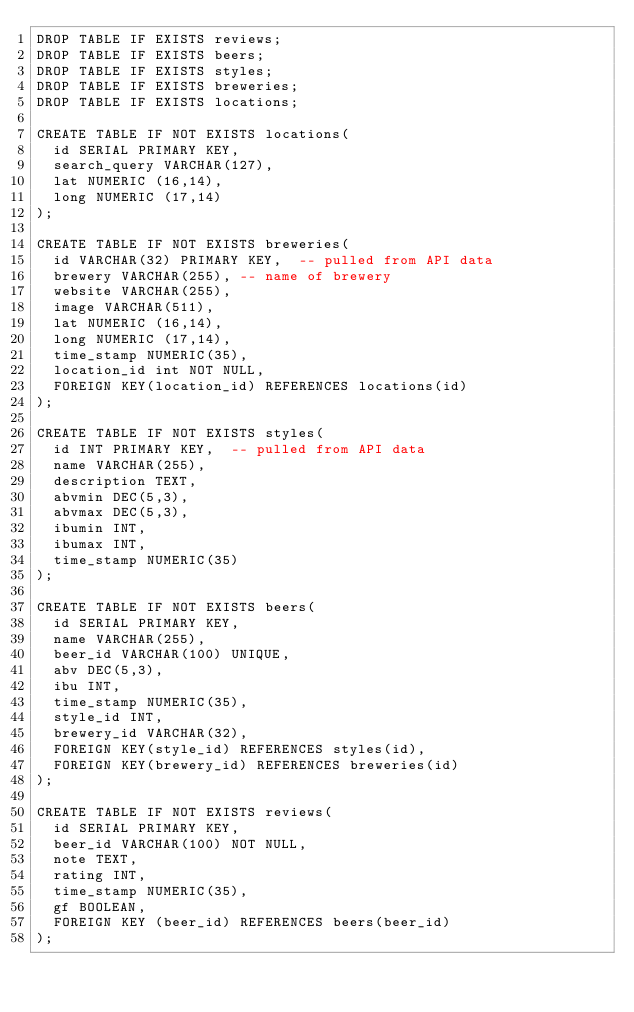Convert code to text. <code><loc_0><loc_0><loc_500><loc_500><_SQL_>DROP TABLE IF EXISTS reviews;
DROP TABLE IF EXISTS beers; 
DROP TABLE IF EXISTS styles;
DROP TABLE IF EXISTS breweries;
DROP TABLE IF EXISTS locations;

CREATE TABLE IF NOT EXISTS locations(
  id SERIAL PRIMARY KEY,
  search_query VARCHAR(127),
  lat NUMERIC (16,14),
  long NUMERIC (17,14)
);

CREATE TABLE IF NOT EXISTS breweries(
  id VARCHAR(32) PRIMARY KEY,  -- pulled from API data
  brewery VARCHAR(255), -- name of brewery
  website VARCHAR(255),
  image VARCHAR(511),
  lat NUMERIC (16,14),
  long NUMERIC (17,14),
  time_stamp NUMERIC(35),
  location_id int NOT NULL, 
  FOREIGN KEY(location_id) REFERENCES locations(id)
);

CREATE TABLE IF NOT EXISTS styles(
  id INT PRIMARY KEY,  -- pulled from API data
  name VARCHAR(255), 
  description TEXT,
  abvmin DEC(5,3),
  abvmax DEC(5,3),
  ibumin INT, 
  ibumax INT,
  time_stamp NUMERIC(35)
);

CREATE TABLE IF NOT EXISTS beers(
  id SERIAL PRIMARY KEY, 
  name VARCHAR(255),
  beer_id VARCHAR(100) UNIQUE,
  abv DEC(5,3),
  ibu INT,
  time_stamp NUMERIC(35),
  style_id INT,
  brewery_id VARCHAR(32),
  FOREIGN KEY(style_id) REFERENCES styles(id),
  FOREIGN KEY(brewery_id) REFERENCES breweries(id)
);

CREATE TABLE IF NOT EXISTS reviews(
  id SERIAL PRIMARY KEY,
  beer_id VARCHAR(100) NOT NULL,
  note TEXT,
  rating INT,
  time_stamp NUMERIC(35),
  gf BOOLEAN,
  FOREIGN KEY (beer_id) REFERENCES beers(beer_id)
);
</code> 